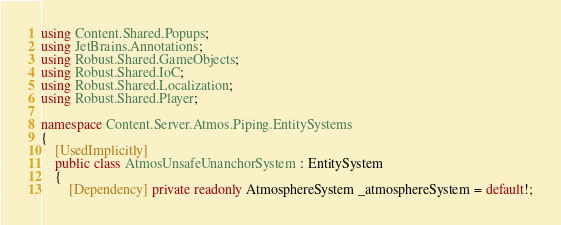Convert code to text. <code><loc_0><loc_0><loc_500><loc_500><_C#_>using Content.Shared.Popups;
using JetBrains.Annotations;
using Robust.Shared.GameObjects;
using Robust.Shared.IoC;
using Robust.Shared.Localization;
using Robust.Shared.Player;

namespace Content.Server.Atmos.Piping.EntitySystems
{
    [UsedImplicitly]
    public class AtmosUnsafeUnanchorSystem : EntitySystem
    {
        [Dependency] private readonly AtmosphereSystem _atmosphereSystem = default!;</code> 